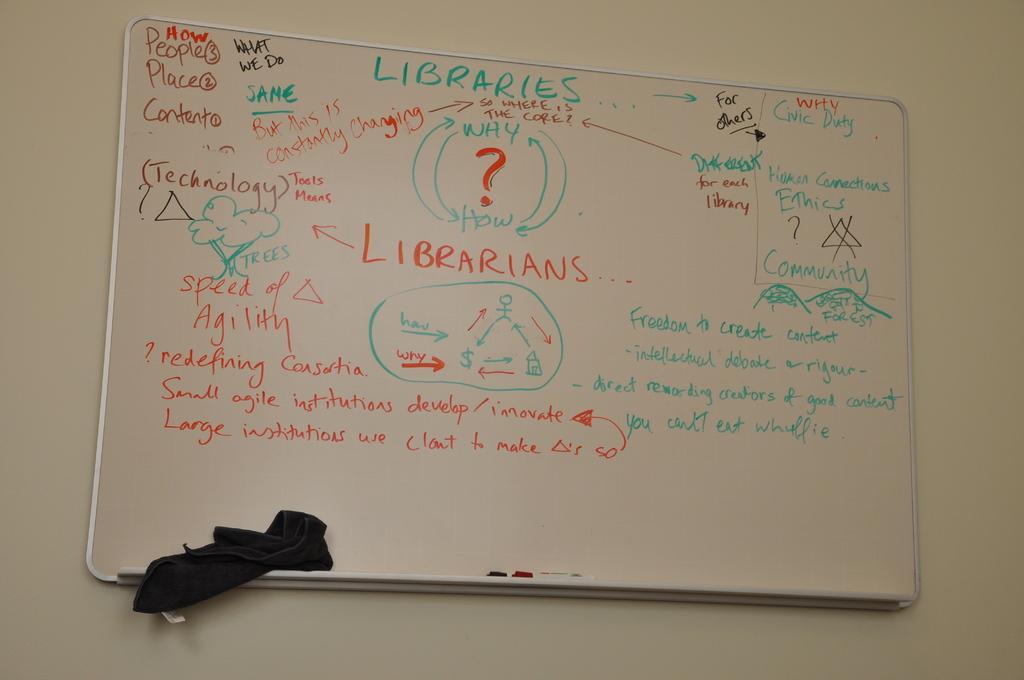Please provide a concise description of this image. There are texts and drawings on the white color board. This board is attached to the white wall. 